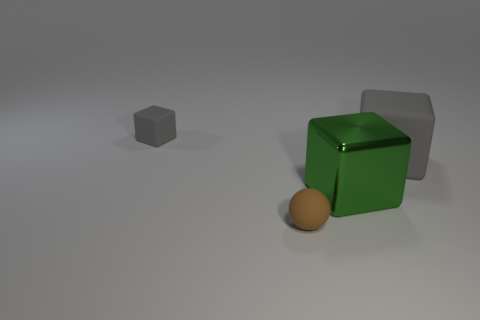Add 1 green metal objects. How many objects exist? 5 Subtract all cubes. How many objects are left? 1 Add 3 small spheres. How many small spheres are left? 4 Add 2 large gray rubber cubes. How many large gray rubber cubes exist? 3 Subtract 0 cyan spheres. How many objects are left? 4 Subtract all metallic things. Subtract all tiny spheres. How many objects are left? 2 